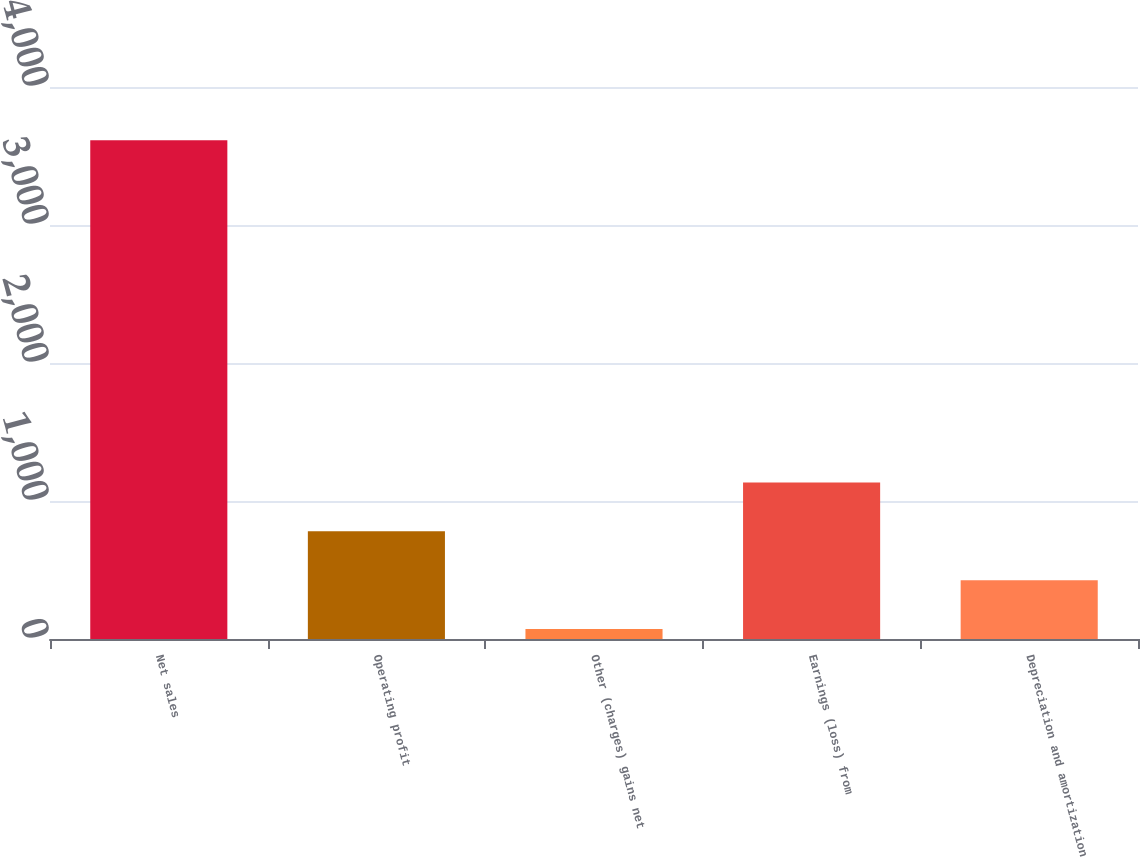<chart> <loc_0><loc_0><loc_500><loc_500><bar_chart><fcel>Net sales<fcel>Operating profit<fcel>Other (charges) gains net<fcel>Earnings (loss) from<fcel>Depreciation and amortization<nl><fcel>3615<fcel>780.6<fcel>72<fcel>1134.9<fcel>426.3<nl></chart> 